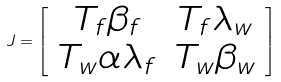<formula> <loc_0><loc_0><loc_500><loc_500>J = \left [ \begin{array} { c c } T _ { f } \beta _ { f } & T _ { f } \lambda _ { w } \\ T _ { w } \alpha \lambda _ { f } & T _ { w } \beta _ { w } \end{array} \right ]</formula> 